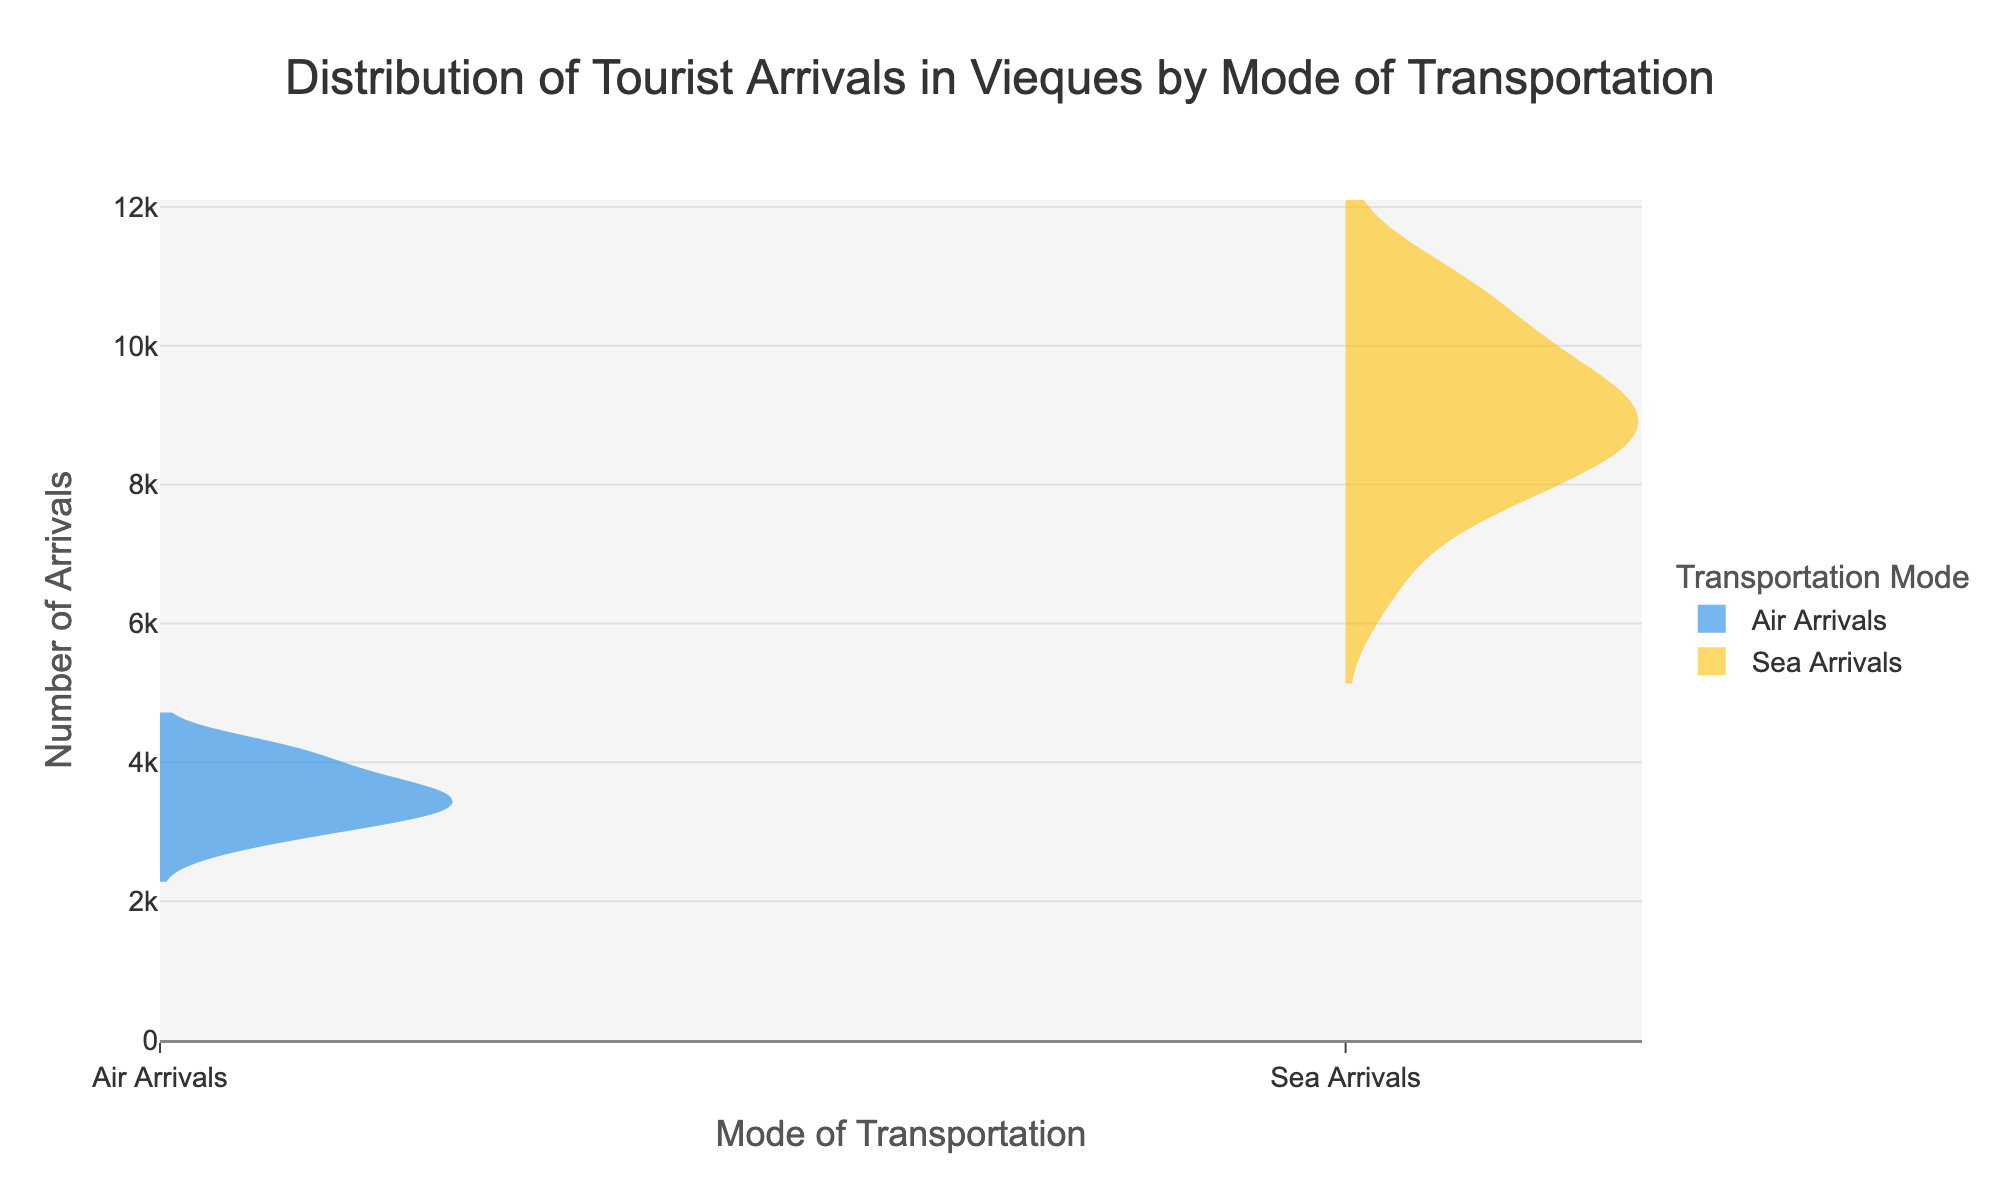What is the title of the plot? The title is displayed prominently at the top of the plot, indicating the overall subject of the figure.
Answer: Distribution of Tourist Arrivals in Vieques by Mode of Transportation What modes of transportation are compared in the plot? Look at the names labeled on the plot, representing different groups being compared.
Answer: Air Arrivals and Sea Arrivals Which mode of transportation has a wider range of tourist arrivals? Observe the length of the violins in the plot, as a wider violin suggests a broader range.
Answer: Sea Arrivals Is the median number of sea arrivals higher or lower than that of air arrivals? Notice the central line in each violin plot, which represents the median value. Compare their positions.
Answer: Higher During which period do air arrivals show the highest concentration? Identify the densest area in the violin plot for air arrivals, where the plot is thickest.
Answer: December 2022 and March 2023 What's the approximate range of air arrivals? Look at the top and bottom of the air arrivals' violin plot to determine the range from the highest to the lowest point.
Answer: 2800 to 4200 Which months show a significant difference between air arrivals and sea arrivals? Compare the density of both groups for each month to find months with visible disparities in arrivals.
Answer: December 2022 and March 2023 have significant differences In which mode of transportation is the deviation from the median larger? Compare the spread of data points around the median line in both violin plots.
Answer: Sea Arrivals What can you say about the seasonality of tourist arrivals by plane? Evaluate the plot for any visible patterns or peaks recurring at certain times of the year.
Answer: Higher arrivals in the winter months 